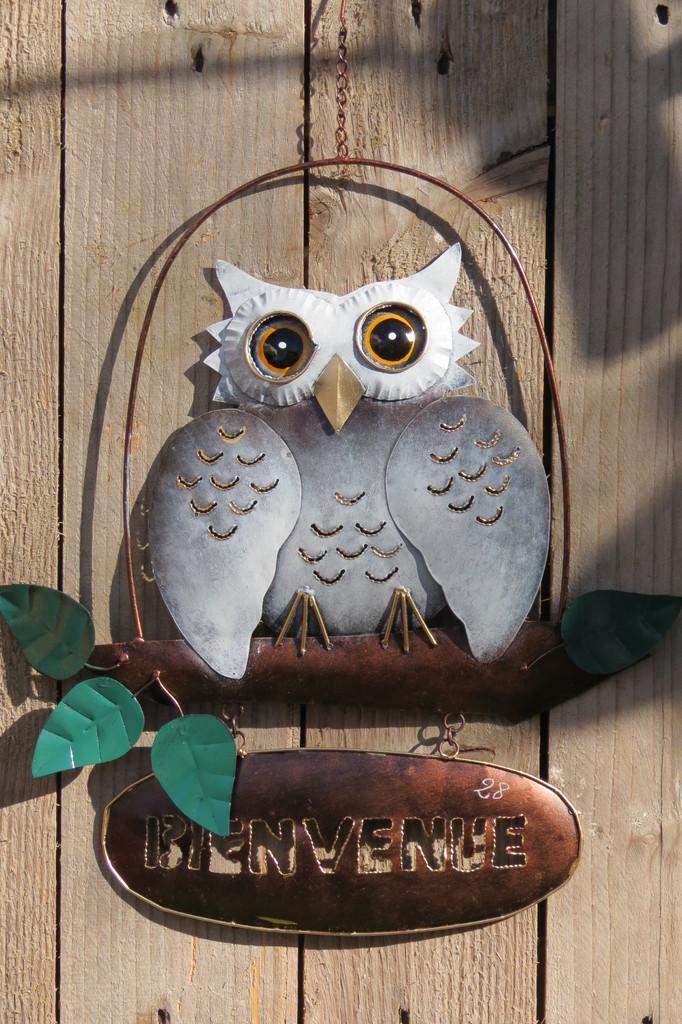Can you describe this image briefly? In the picture I can see an owl wall hanging hanged to the wooden wall. Here I can see some text on the board. 